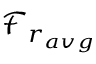<formula> <loc_0><loc_0><loc_500><loc_500>\mathcal { F } _ { r _ { a v g } }</formula> 